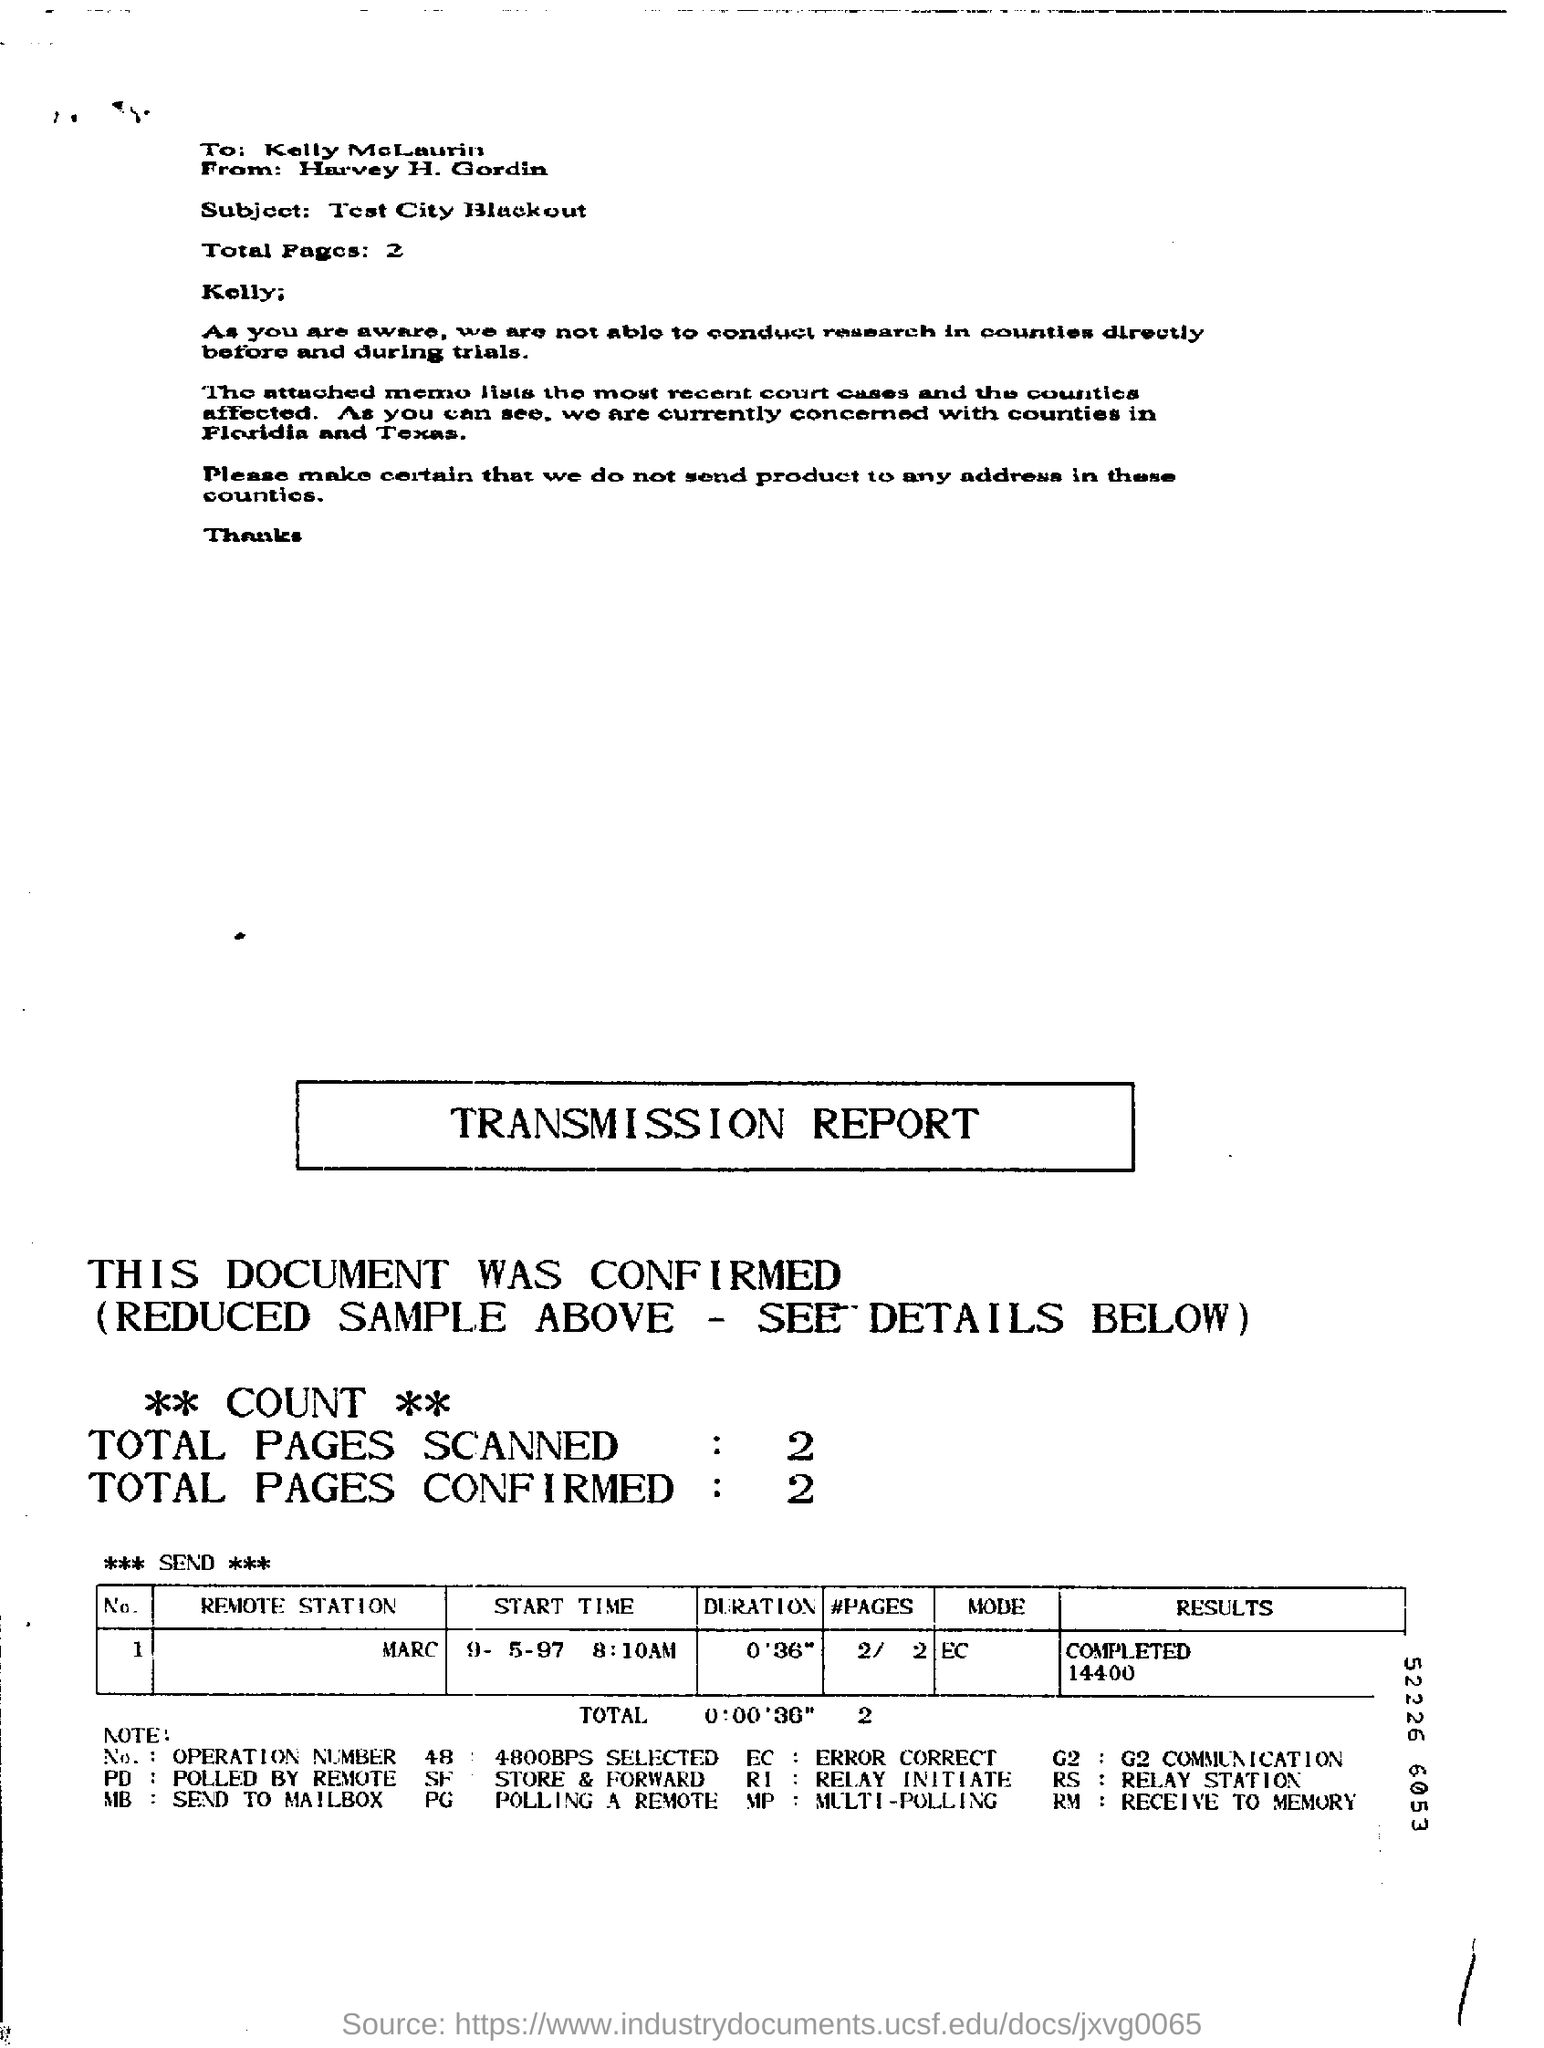List a handful of essential elements in this visual. The name of the remote station is Marc. The total number of confirmed pages is 2. The total number of pages is 2.. 